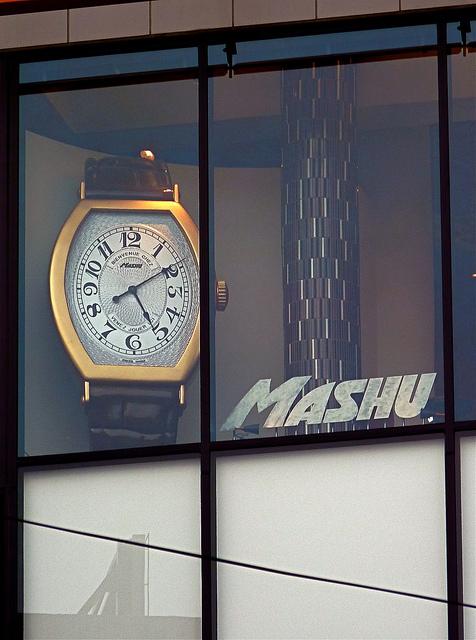What time is it?
Write a very short answer. 5:10. What color is the watch?
Answer briefly. Gold. What brand is shown?
Write a very short answer. Mashu. Does the paint around the window need to be touched up?
Give a very brief answer. No. IS IT 5:10?
Quick response, please. Yes. 